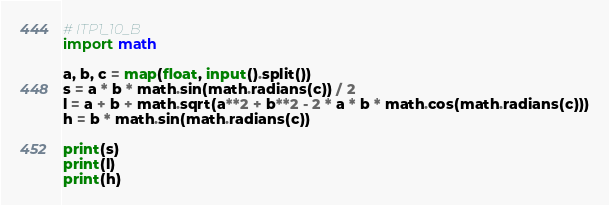<code> <loc_0><loc_0><loc_500><loc_500><_Python_># ITP1_10_B
import math

a, b, c = map(float, input().split())
s = a * b * math.sin(math.radians(c)) / 2
l = a + b + math.sqrt(a**2 + b**2 - 2 * a * b * math.cos(math.radians(c)))
h = b * math.sin(math.radians(c))

print(s)
print(l)
print(h)

</code> 